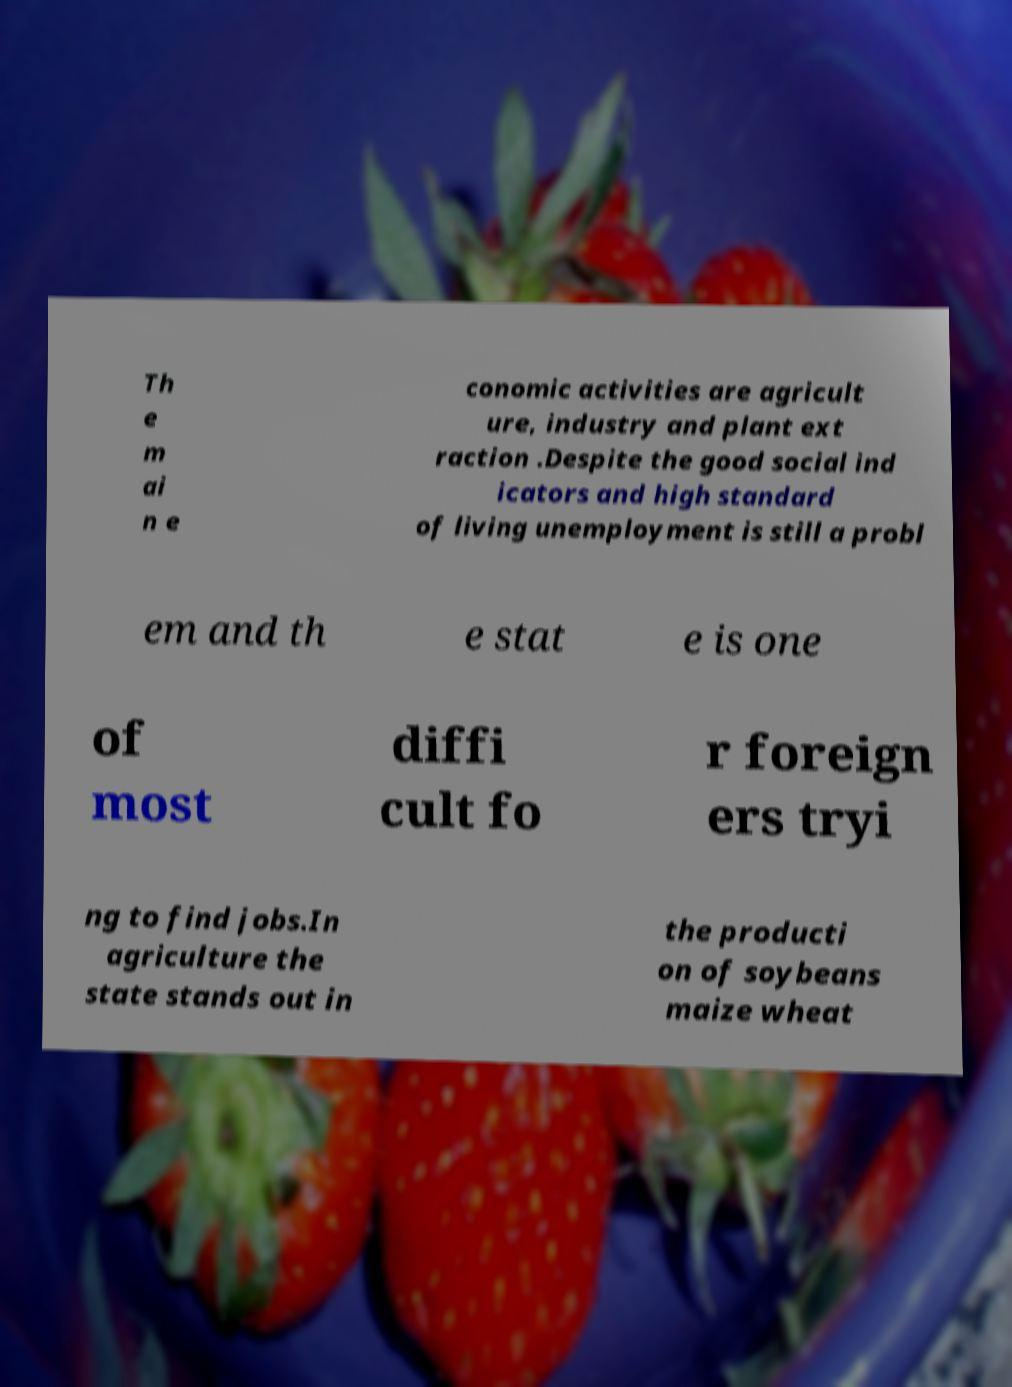Please identify and transcribe the text found in this image. Th e m ai n e conomic activities are agricult ure, industry and plant ext raction .Despite the good social ind icators and high standard of living unemployment is still a probl em and th e stat e is one of most diffi cult fo r foreign ers tryi ng to find jobs.In agriculture the state stands out in the producti on of soybeans maize wheat 